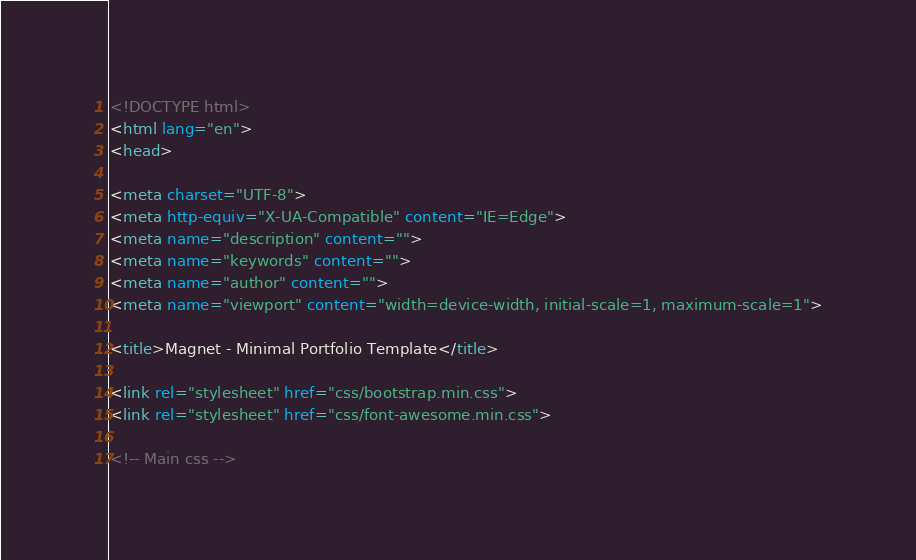Convert code to text. <code><loc_0><loc_0><loc_500><loc_500><_HTML_><!DOCTYPE html>
<html lang="en">
<head>

<meta charset="UTF-8">
<meta http-equiv="X-UA-Compatible" content="IE=Edge">
<meta name="description" content="">
<meta name="keywords" content="">
<meta name="author" content="">
<meta name="viewport" content="width=device-width, initial-scale=1, maximum-scale=1">

<title>Magnet - Minimal Portfolio Template</title>

<link rel="stylesheet" href="css/bootstrap.min.css">
<link rel="stylesheet" href="css/font-awesome.min.css">

<!-- Main css --></code> 